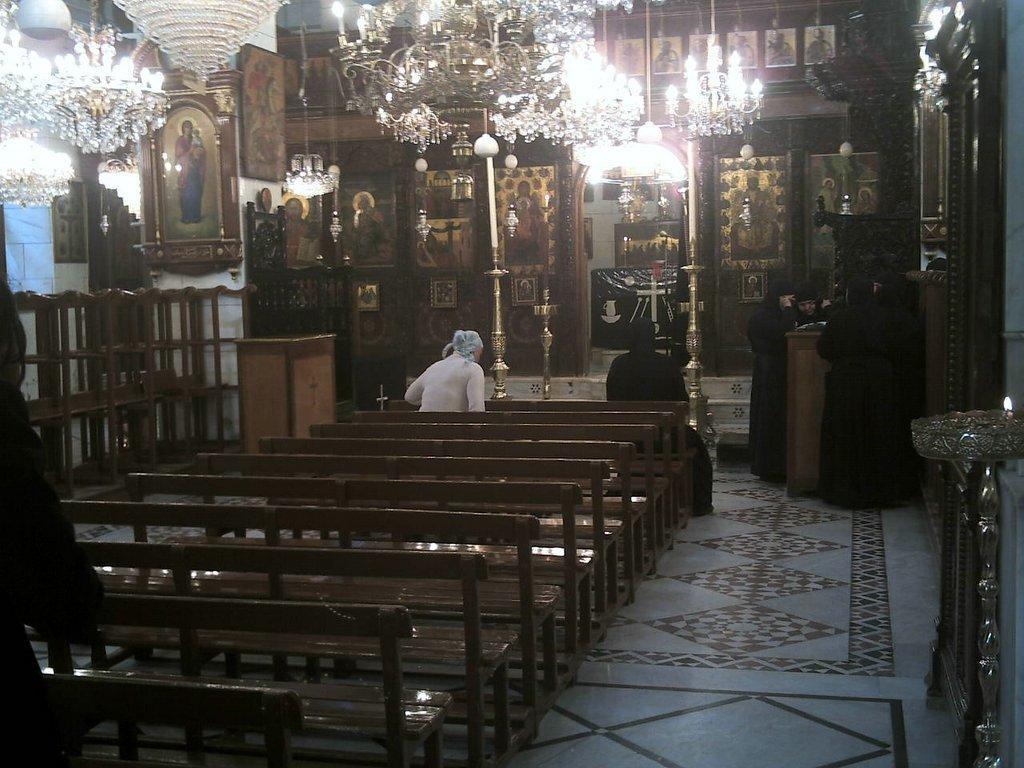Describe this image in one or two sentences. Inside the room there are benches with two ladies are sitting, there is a podium, walls with frames, pillar with frames, poles and to the wall there is an arch shape. At the top of the image there are chandeliers. 